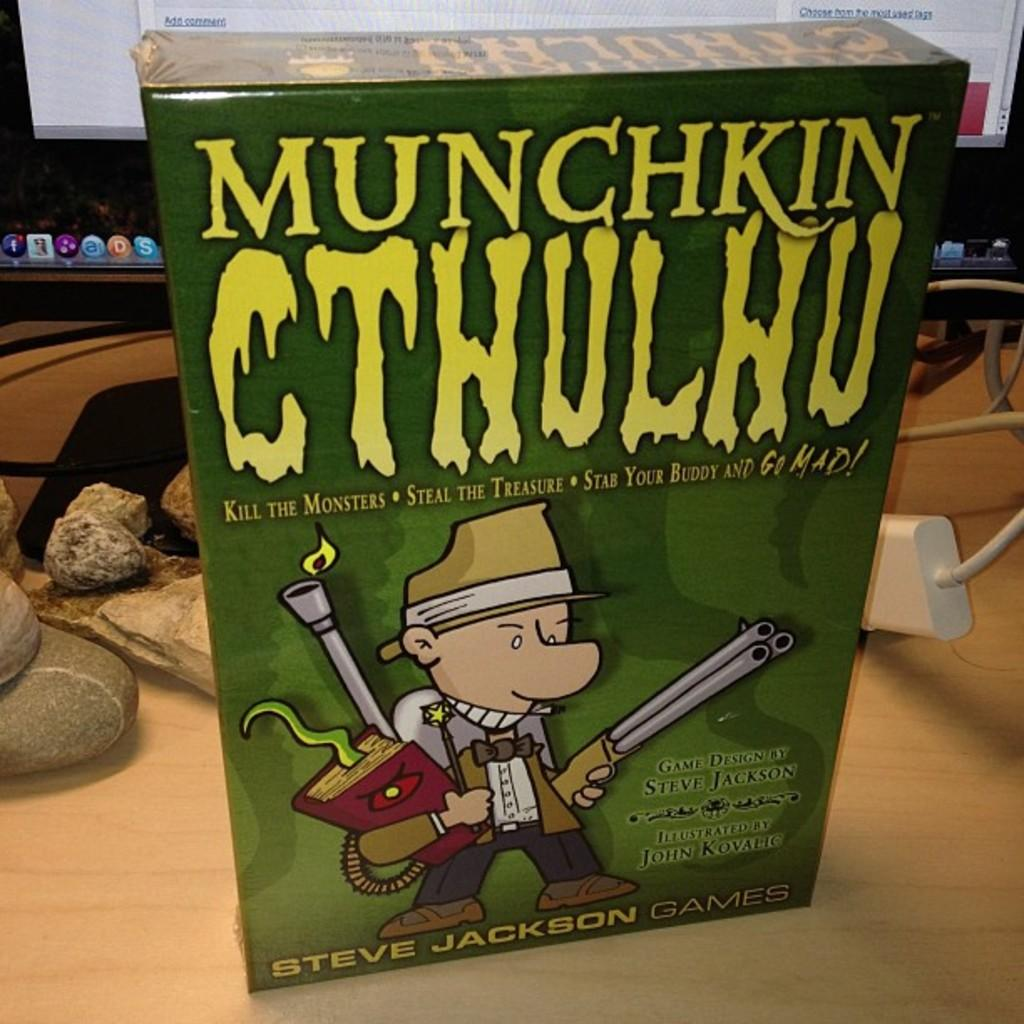Provide a one-sentence caption for the provided image. A boxed PC game called Munchkin Cthulhu sits on a desk in front of a monitor. 